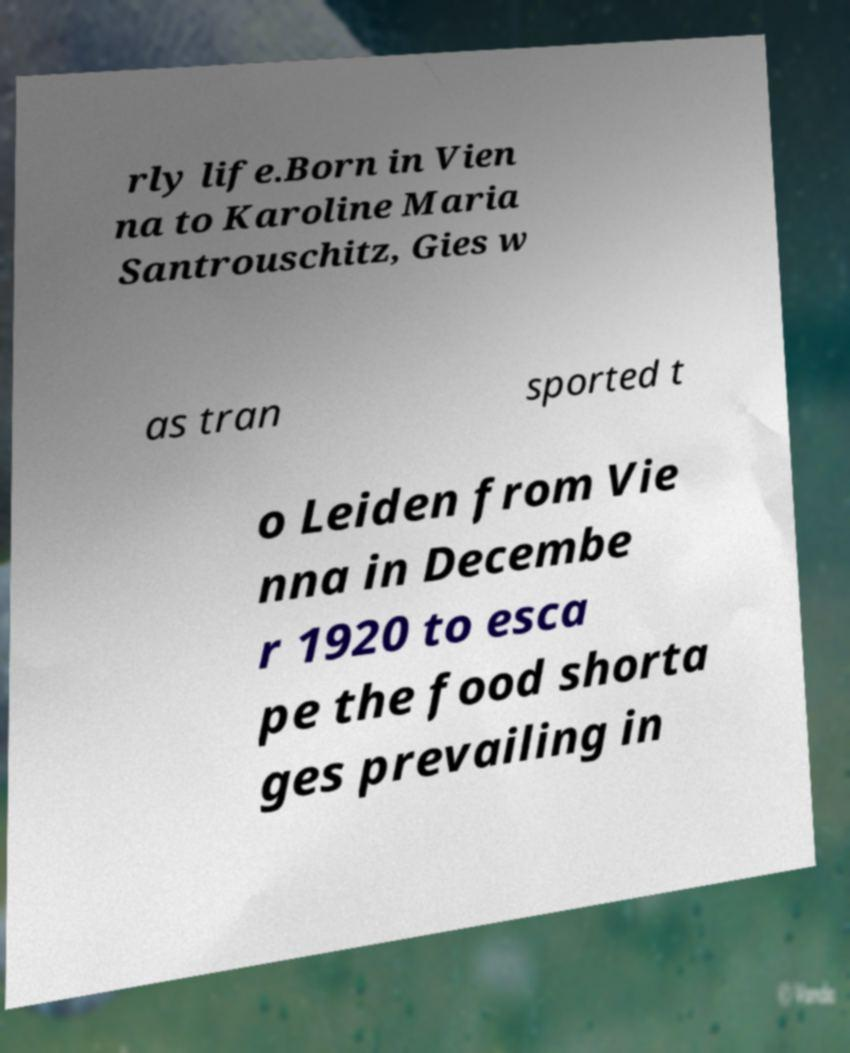I need the written content from this picture converted into text. Can you do that? rly life.Born in Vien na to Karoline Maria Santrouschitz, Gies w as tran sported t o Leiden from Vie nna in Decembe r 1920 to esca pe the food shorta ges prevailing in 